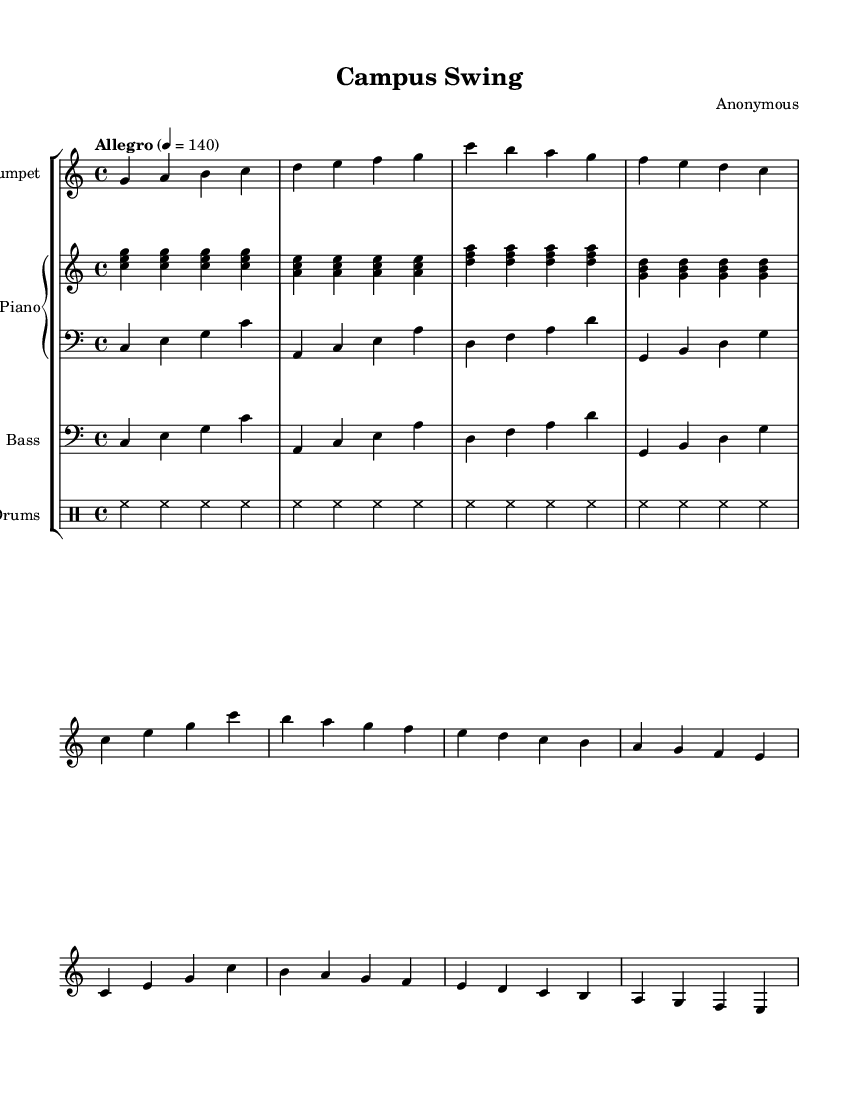What is the key signature of this music? The key signature is C major, identified by the lack of sharps or flats in the notation. This can be confirmed by counting the number of accidentals at the beginning of the staff.
Answer: C major What is the time signature of this music? The time signature is 4/4, indicated at the beginning of the score with the numbers “4” over “4.” This means there are four beats in each measure, and the quarter note gets one beat.
Answer: 4/4 What is the tempo marking of this piece? The tempo marking indicates "Allegro" and is set at a quarter note equals 140 BPM. It is shown near the top of the music, providing guidance on the speed of performance.
Answer: Allegro, 140 How many measures are there in the A section of the composition? The A section contains 8 measures, as noted in the score under the section labeled A, and can be counted directly from the notation.
Answer: 8 What is the primary rhythmic style represented in the drumming part? The drumming part showcases a basic swing pattern, characterized by the use of hi-hats and an uneven rhythmic feel typical of jazz music. This can be inferred from the notation indicating the rhythm type.
Answer: Swing What instruments are included in this score? The instruments featured in this score are trumpet, piano, bass, and drums, each represented by distinct staffs labeled accordingly. This information can be gathered by examining the instrument names listed at the beginning of each staff.
Answer: Trumpet, piano, bass, drums What is the range of the trumpet melody in the piece? The trumpet melody ranges from G to C in its written pitch, as seen in the notated notes across the staff. This range can be determined by observing the highest and lowest notes played in the composition.
Answer: G to C 